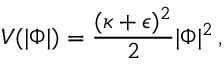<formula> <loc_0><loc_0><loc_500><loc_500>V ( | \Phi | ) = { \frac { ( \kappa + \epsilon ) ^ { 2 } } { 2 } } | \Phi | ^ { 2 } \, ,</formula> 